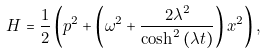Convert formula to latex. <formula><loc_0><loc_0><loc_500><loc_500>H = \frac { 1 } { 2 } \left ( p ^ { 2 } + \left ( \omega ^ { 2 } + \frac { 2 \lambda ^ { 2 } } { \cosh ^ { 2 } \left ( \lambda t \right ) } \right ) x ^ { 2 } \right ) ,</formula> 